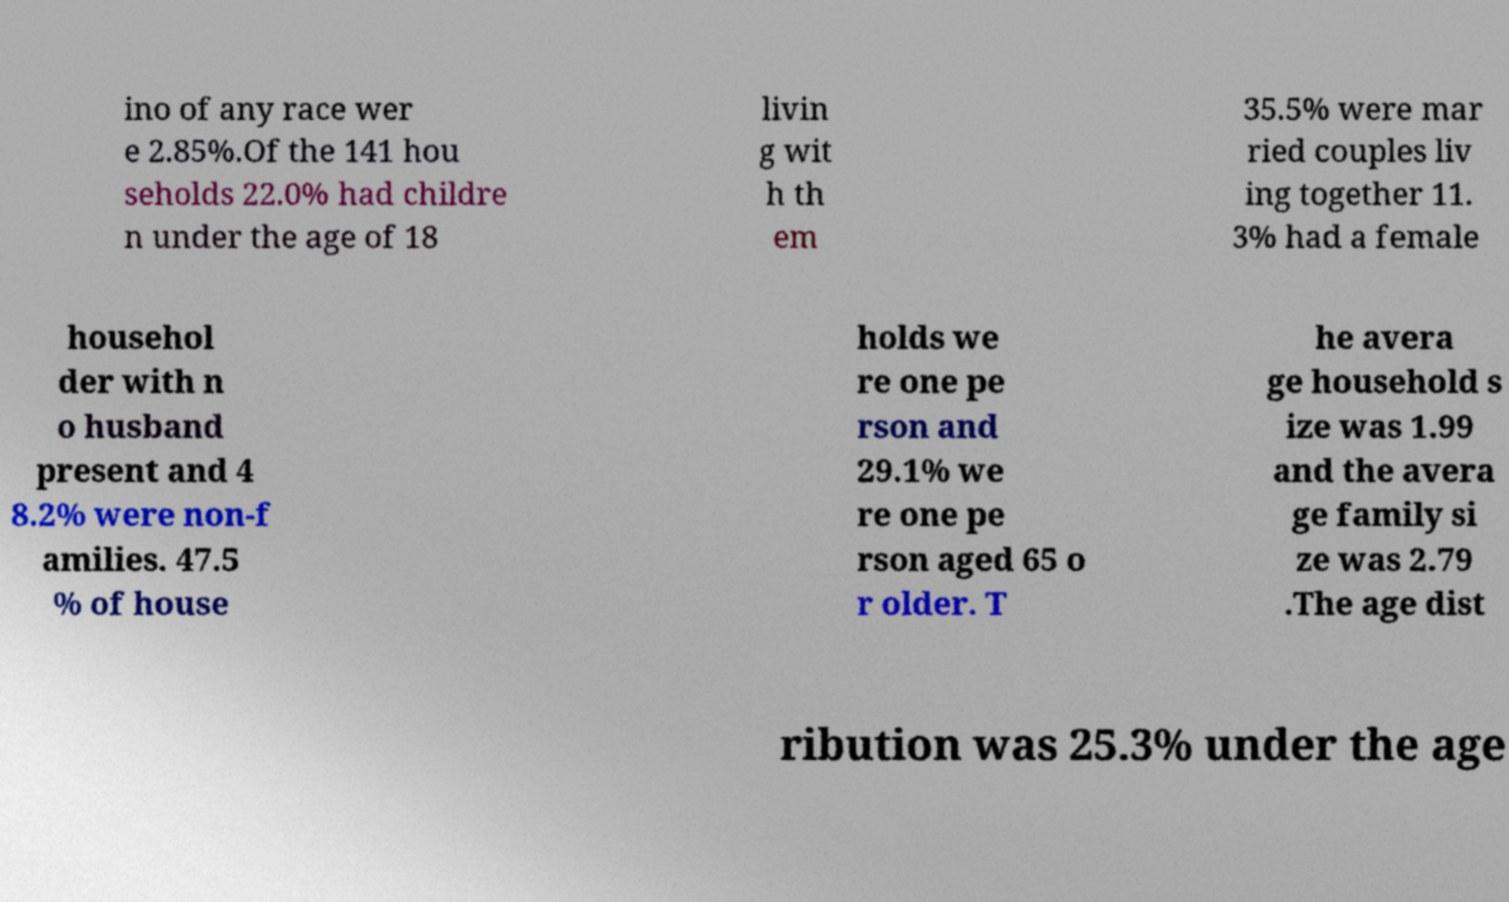I need the written content from this picture converted into text. Can you do that? ino of any race wer e 2.85%.Of the 141 hou seholds 22.0% had childre n under the age of 18 livin g wit h th em 35.5% were mar ried couples liv ing together 11. 3% had a female househol der with n o husband present and 4 8.2% were non-f amilies. 47.5 % of house holds we re one pe rson and 29.1% we re one pe rson aged 65 o r older. T he avera ge household s ize was 1.99 and the avera ge family si ze was 2.79 .The age dist ribution was 25.3% under the age 